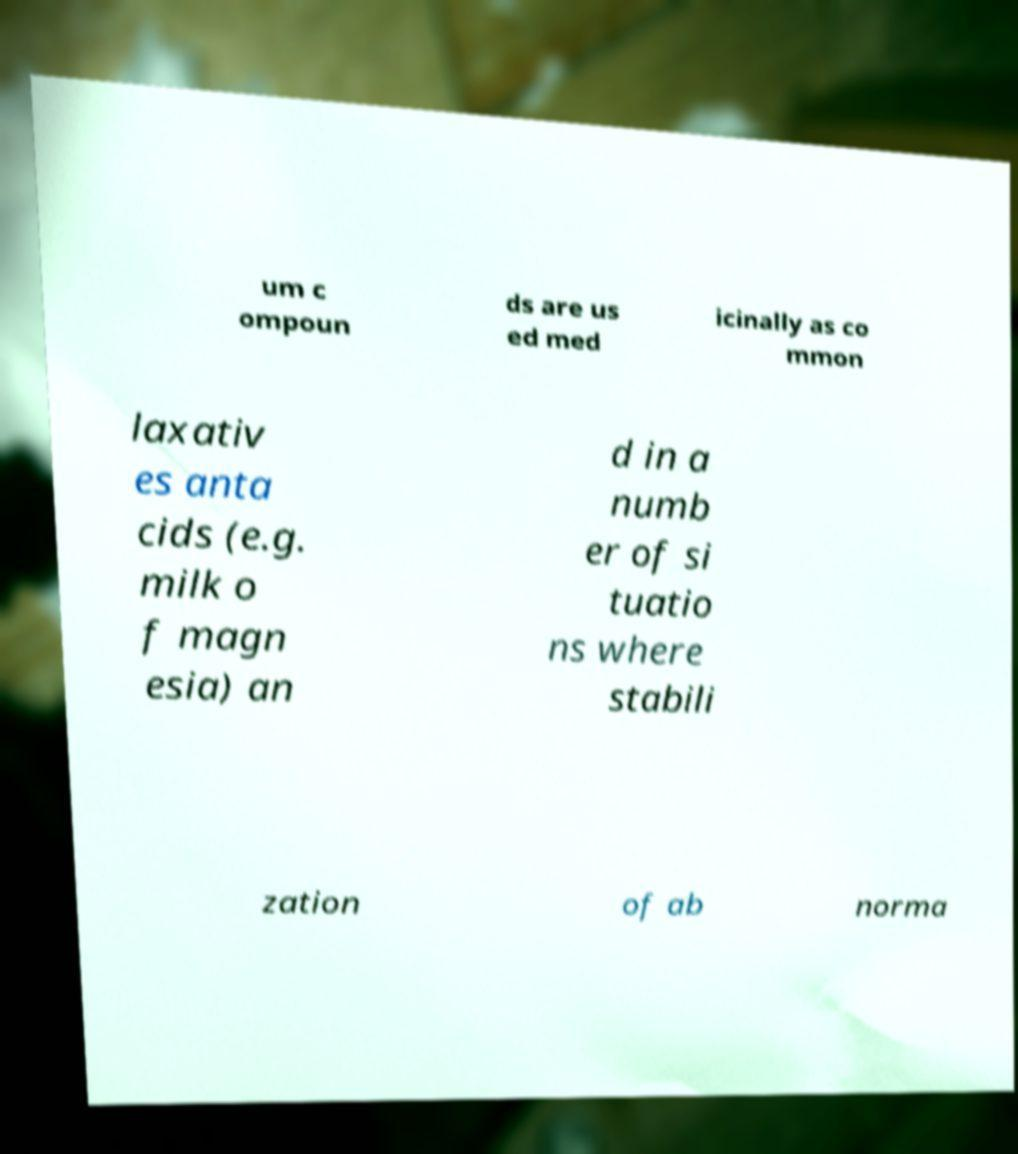I need the written content from this picture converted into text. Can you do that? um c ompoun ds are us ed med icinally as co mmon laxativ es anta cids (e.g. milk o f magn esia) an d in a numb er of si tuatio ns where stabili zation of ab norma 